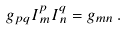<formula> <loc_0><loc_0><loc_500><loc_500>g _ { p q } I ^ { p } _ { \, m } I ^ { q } _ { \, n } = g _ { m n } \, .</formula> 